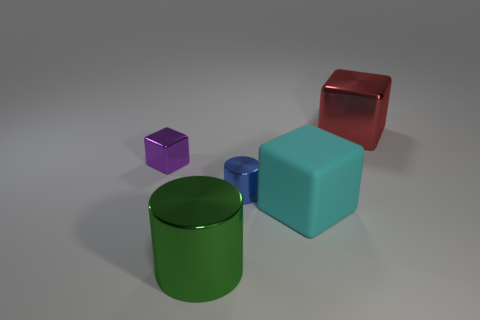The cyan rubber object that is the same shape as the small purple metal thing is what size?
Keep it short and to the point. Large. There is a metal thing in front of the metallic cylinder that is behind the matte block; what shape is it?
Provide a succinct answer. Cylinder. How big is the green object?
Offer a terse response. Large. The blue shiny thing is what shape?
Offer a terse response. Cylinder. Do the large cyan matte thing and the tiny metallic object that is behind the tiny cylinder have the same shape?
Provide a short and direct response. Yes. Do the small shiny thing left of the green thing and the cyan thing have the same shape?
Your answer should be compact. Yes. How many tiny objects are right of the small cube and behind the tiny blue metallic object?
Offer a very short reply. 0. What number of other things are the same size as the red cube?
Make the answer very short. 2. Is the number of purple objects that are to the right of the cyan thing the same as the number of tiny purple rubber balls?
Offer a very short reply. Yes. There is a large shiny thing in front of the purple block; is it the same color as the shiny cube that is to the right of the cyan rubber thing?
Keep it short and to the point. No. 